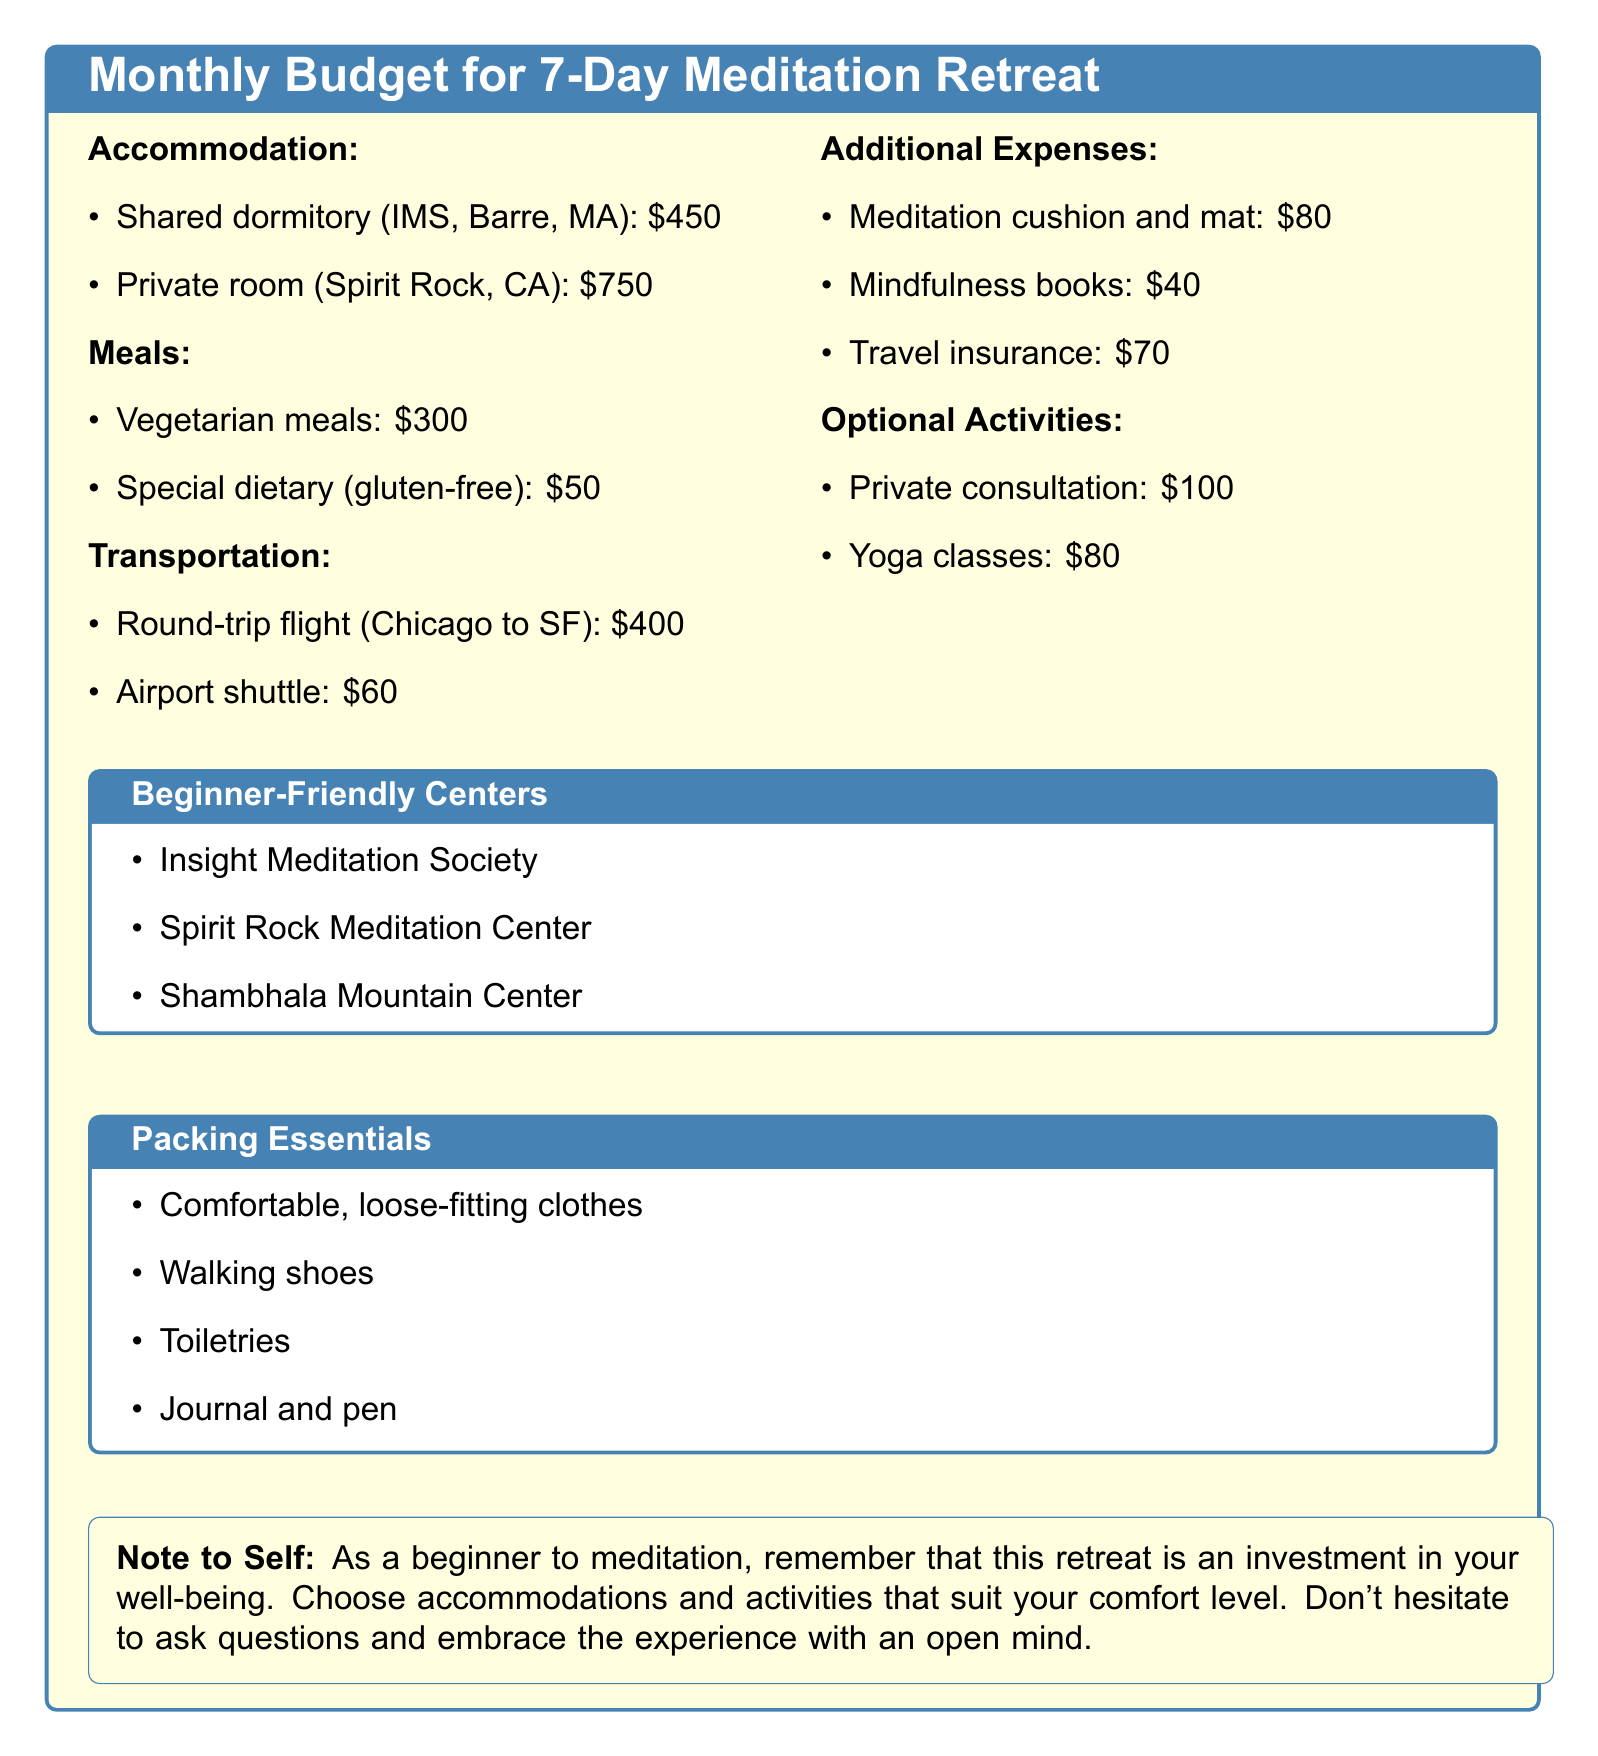What is the cost of shared dormitory accommodation? The cost of shared dormitory accommodation is listed under accommodation expenses in the document.
Answer: $450 What is the price for vegetarian meals? The price for vegetarian meals is mentioned in the meals section of the document.
Answer: $300 How much does a round-trip flight from Chicago to SF cost? The cost of the round-trip flight is specified in the transportation section.
Answer: $400 What is the total cost for private room accommodation and special dietary meals? This requires adding the prices from both accommodation and meals sections, which are 750 + 50.
Answer: $800 Which organization is listed as a beginner-friendly meditation center? The document lists three centers, answering with one of them suffices.
Answer: Insight Meditation Society How much would total additional expenses be? This question requires you to sum up the expenses listed under additional expenses: 80 + 40 + 70.
Answer: $190 What is the price for yoga classes? The price for yoga classes is provided in the optional activities section.
Answer: $80 What should you remember as a note to self? The note emphasizes the importance of mindset for the retreat experience as found in the note to self section.
Answer: Investment in well-being What packing essential is specifically recommended for walking? The packing essentials include specific items suited for comfort while walking.
Answer: Walking shoes 